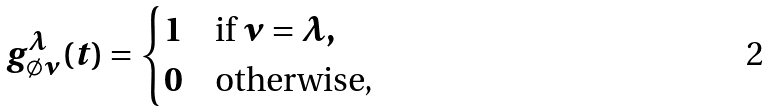Convert formula to latex. <formula><loc_0><loc_0><loc_500><loc_500>g _ { \emptyset \nu } ^ { \lambda } ( t ) = \begin{cases} 1 & \text {if } \nu = \lambda , \\ 0 & \text {otherwise,} \end{cases}</formula> 